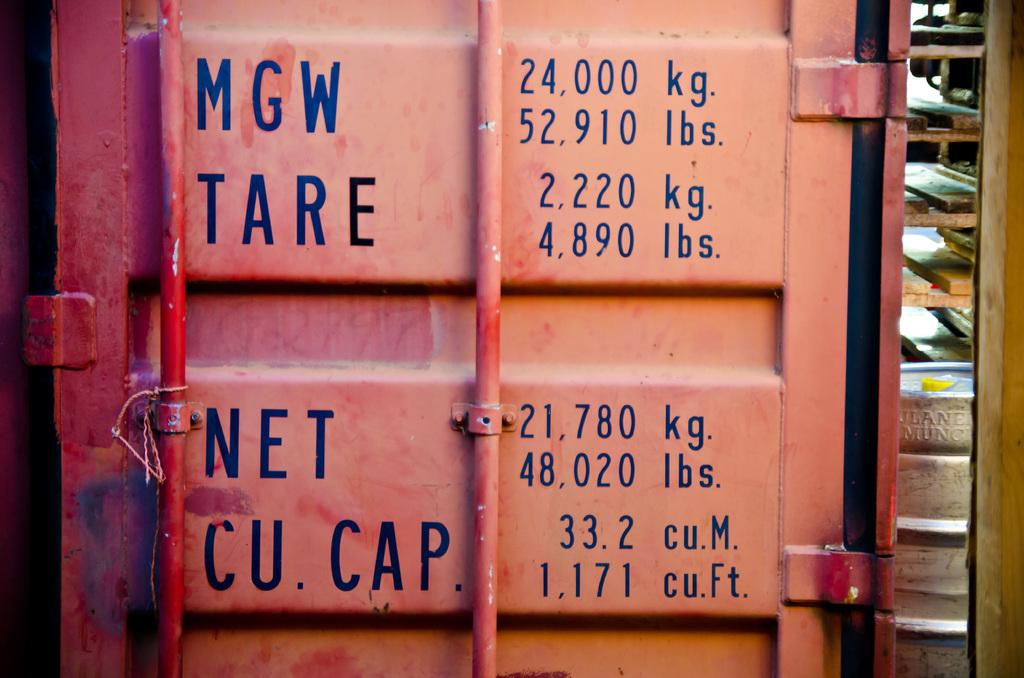What type of door is featured in the image? There is an iron door in the image. What can be seen on the iron door? Words and numbers are written on the iron door. How many trains are visible in the image? There are no trains present in the image. What type of bee can be seen buzzing around the iron door in the image? There are no bees present in the image. 